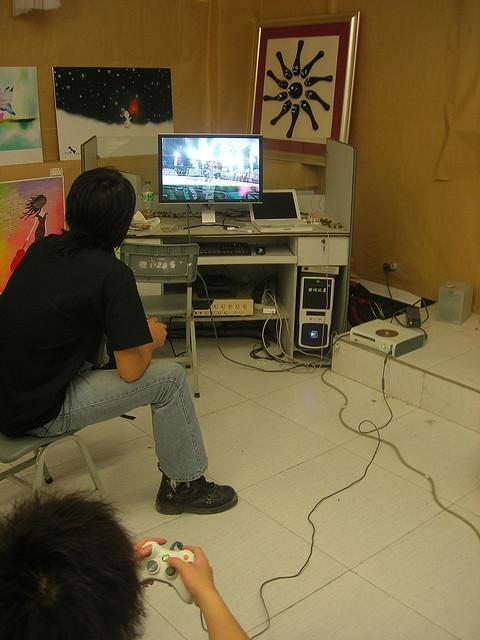How many people are there?
Give a very brief answer. 2. How many chairs are in the photo?
Give a very brief answer. 2. 